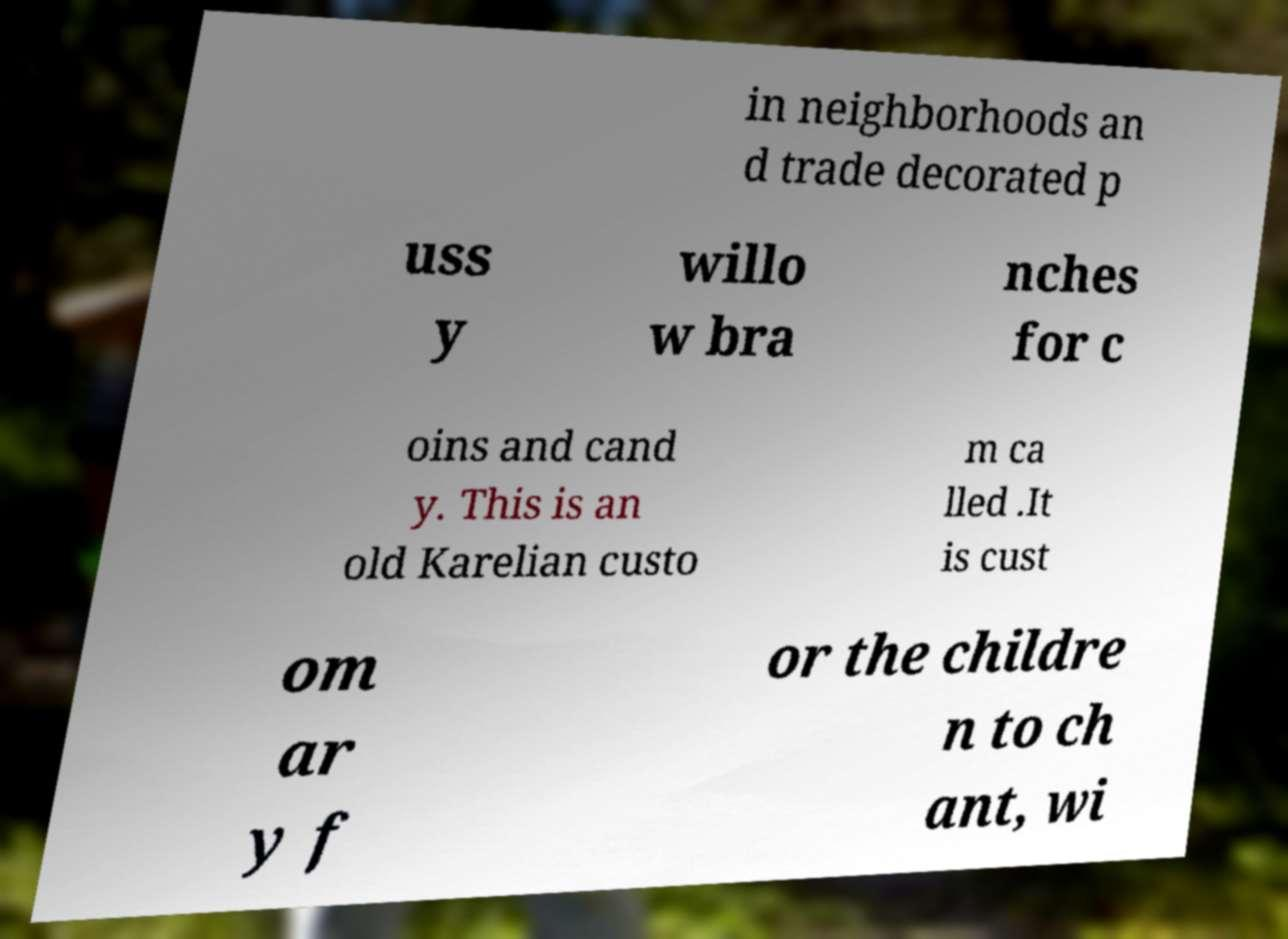Can you read and provide the text displayed in the image?This photo seems to have some interesting text. Can you extract and type it out for me? in neighborhoods an d trade decorated p uss y willo w bra nches for c oins and cand y. This is an old Karelian custo m ca lled .It is cust om ar y f or the childre n to ch ant, wi 